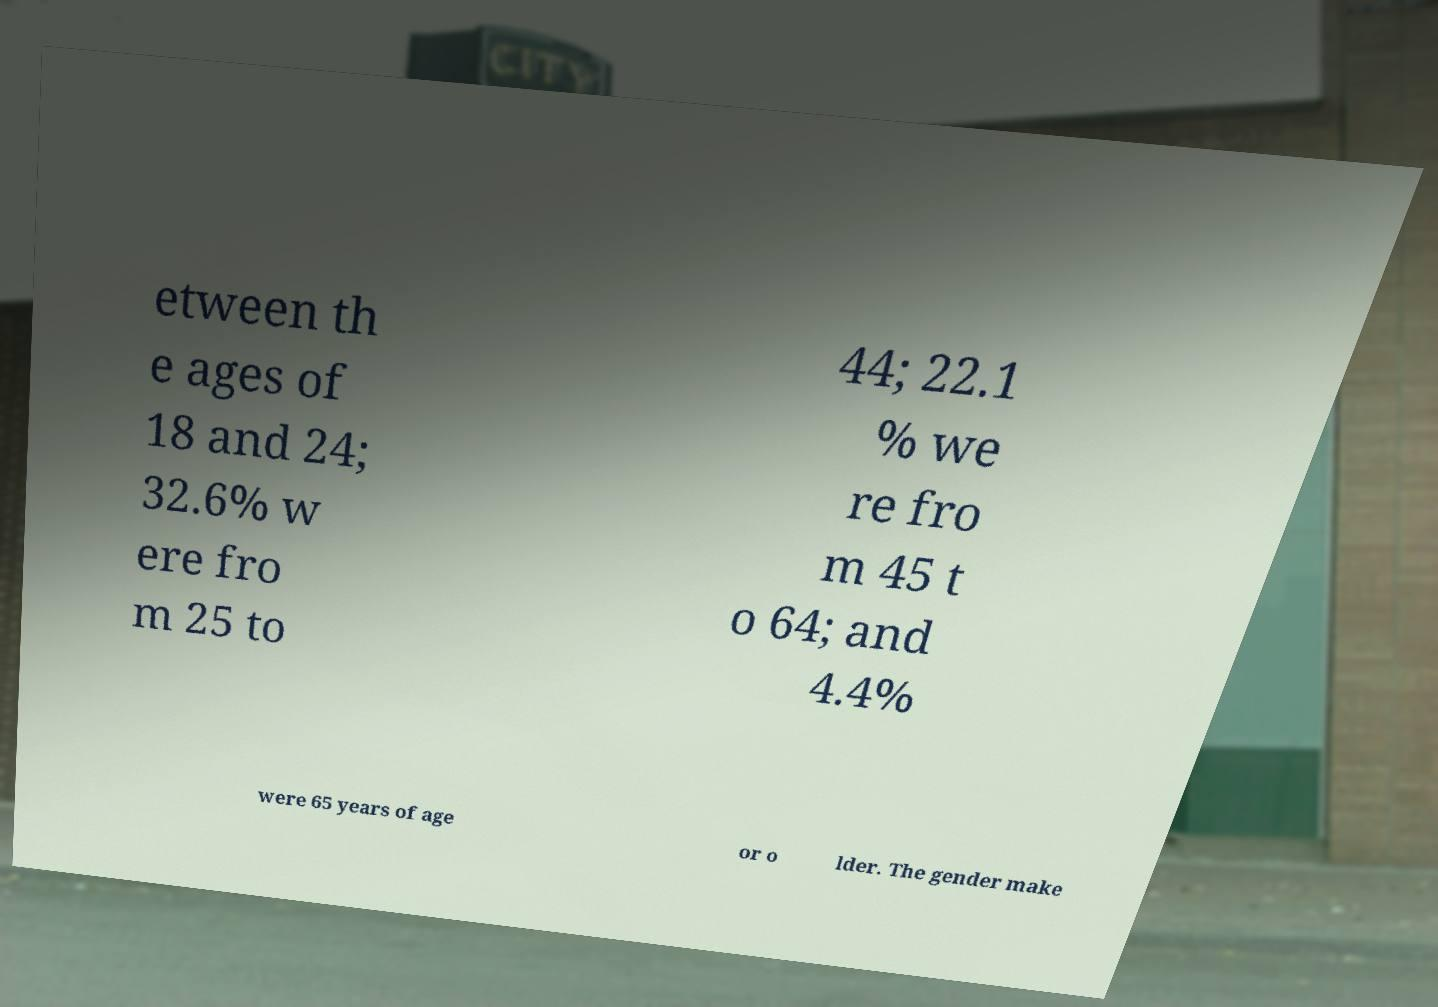Can you accurately transcribe the text from the provided image for me? etween th e ages of 18 and 24; 32.6% w ere fro m 25 to 44; 22.1 % we re fro m 45 t o 64; and 4.4% were 65 years of age or o lder. The gender make 